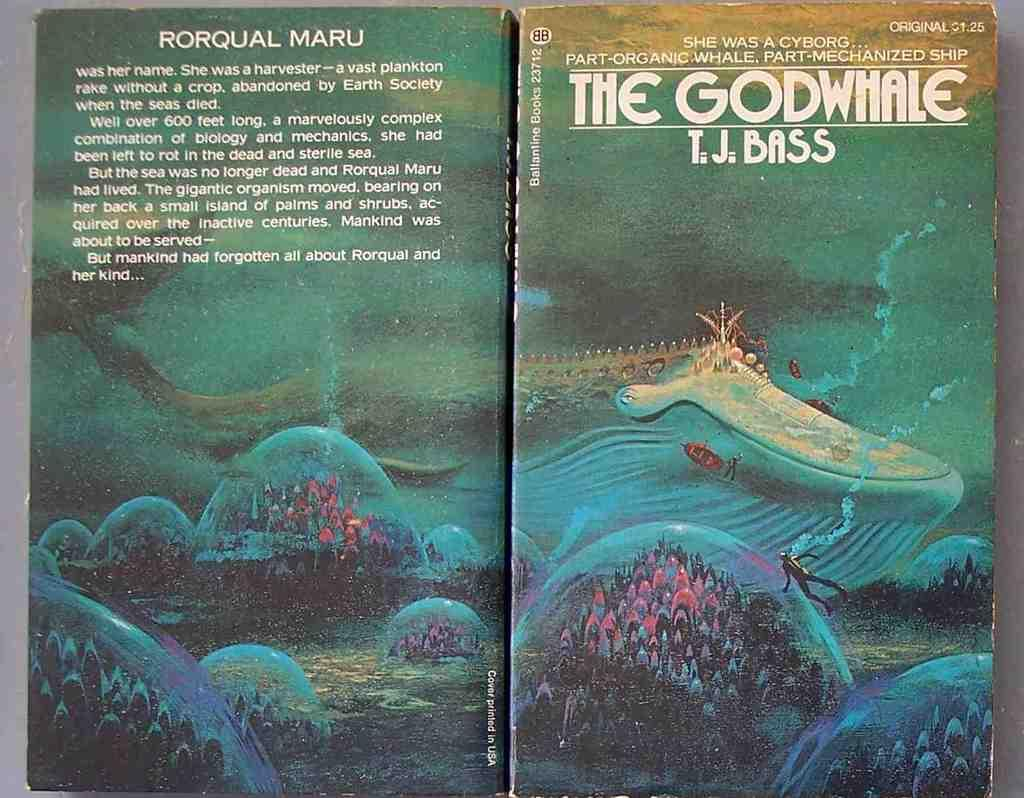<image>
Create a compact narrative representing the image presented. The front and back cover to a book titled The God Whale. 